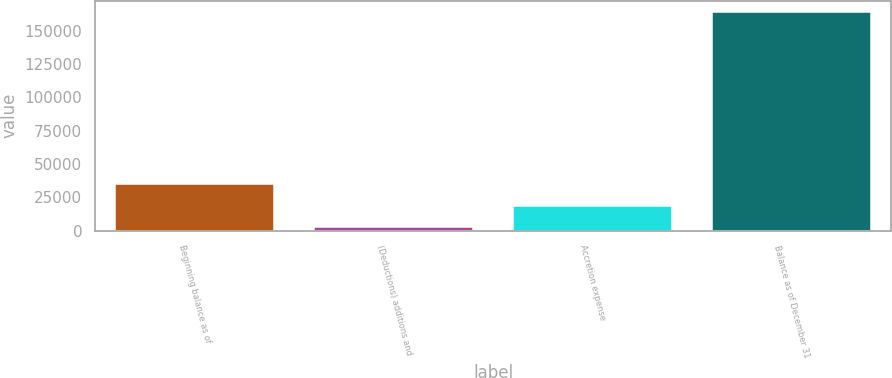Convert chart. <chart><loc_0><loc_0><loc_500><loc_500><bar_chart><fcel>Beginning balance as of<fcel>(Deductions) additions and<fcel>Accretion expense<fcel>Balance as of December 31<nl><fcel>34914<fcel>2587<fcel>18750.5<fcel>164222<nl></chart> 